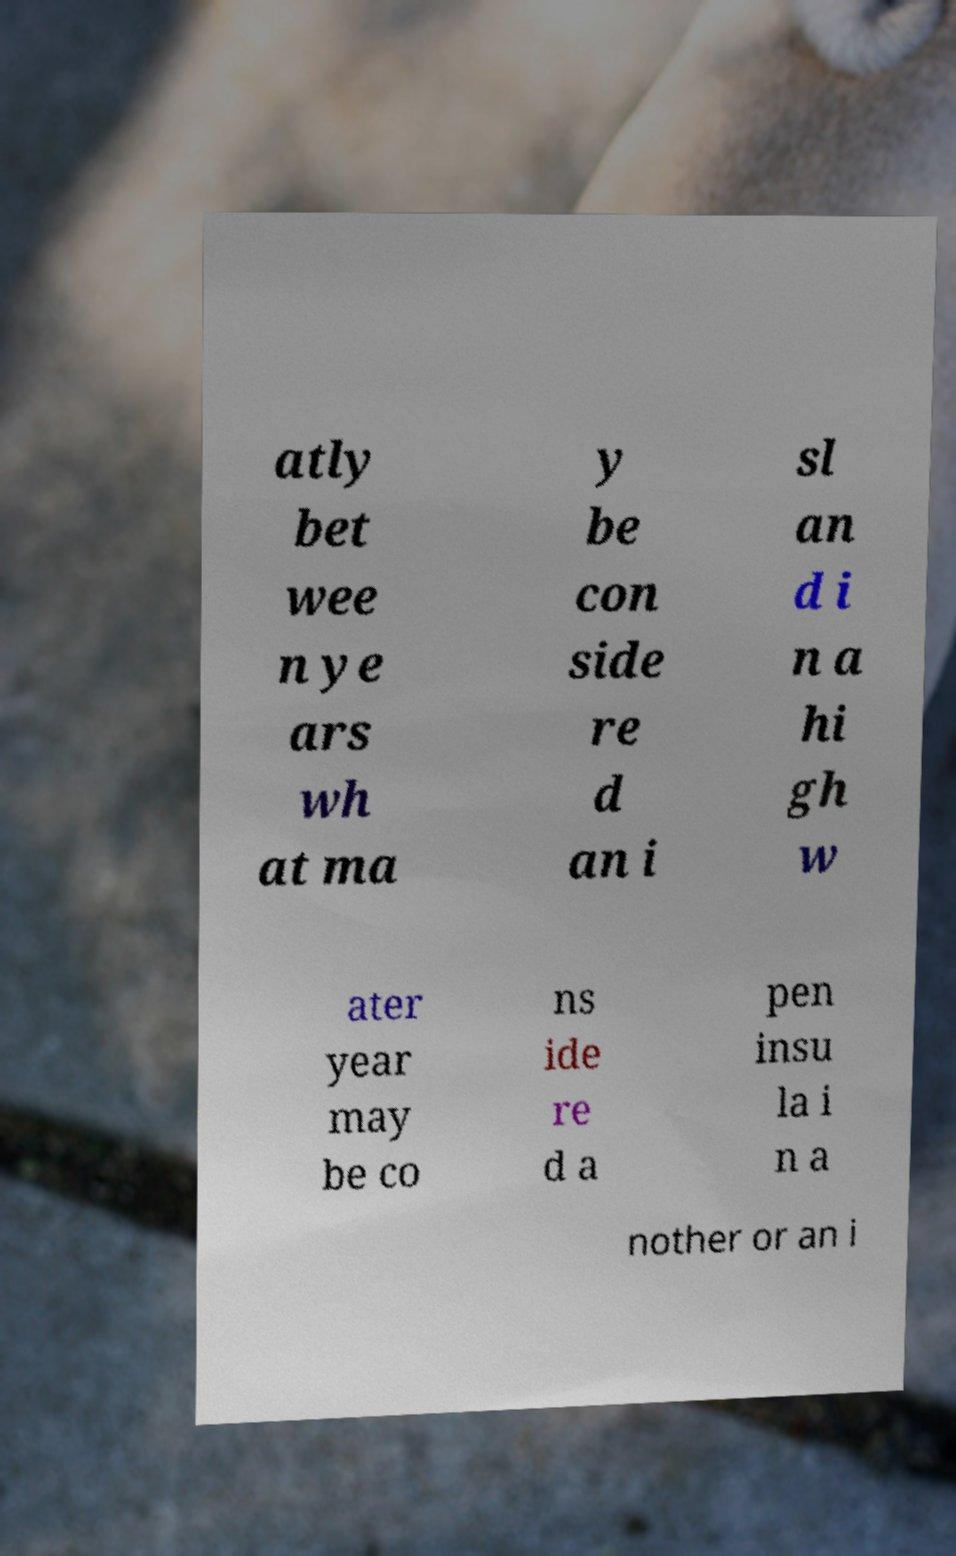I need the written content from this picture converted into text. Can you do that? atly bet wee n ye ars wh at ma y be con side re d an i sl an d i n a hi gh w ater year may be co ns ide re d a pen insu la i n a nother or an i 